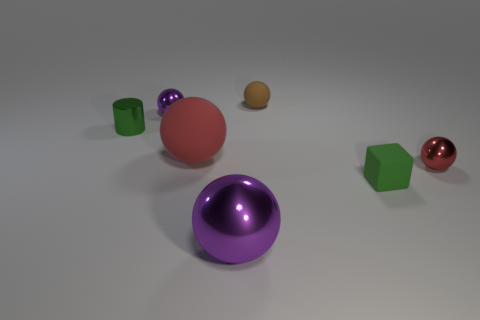There is a green object that is the same material as the brown sphere; what is its size? The green object that shares the same material as the brown sphere appears to be medium in size when compared to the other objects surrounding it. 